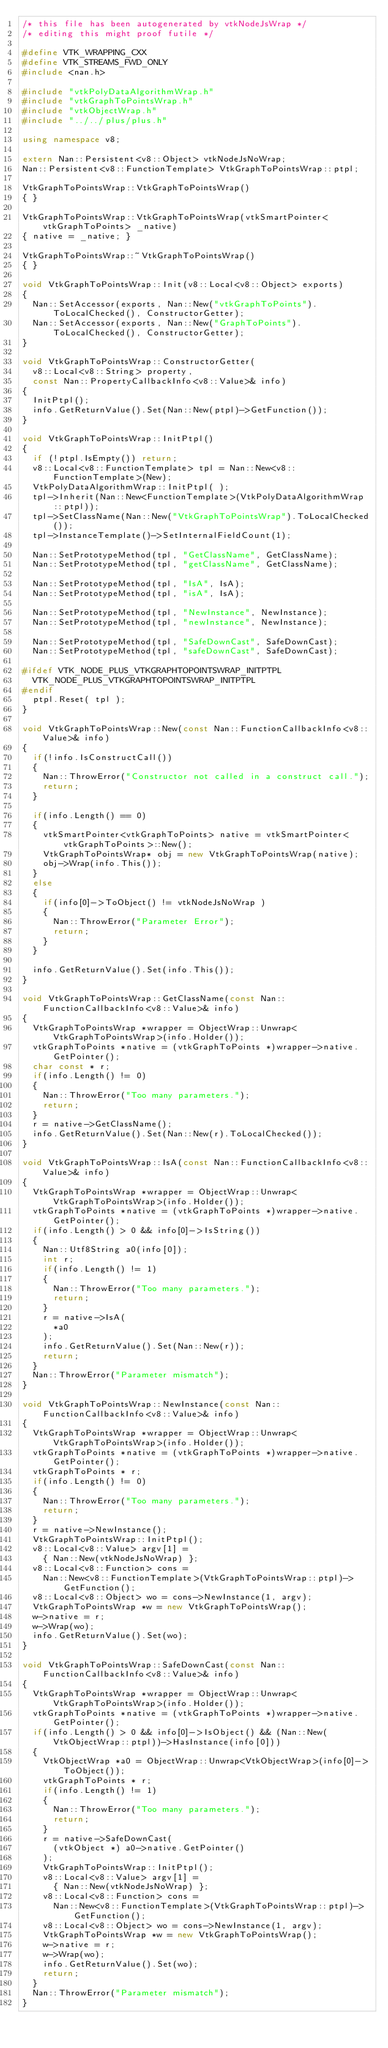Convert code to text. <code><loc_0><loc_0><loc_500><loc_500><_C++_>/* this file has been autogenerated by vtkNodeJsWrap */
/* editing this might proof futile */

#define VTK_WRAPPING_CXX
#define VTK_STREAMS_FWD_ONLY
#include <nan.h>

#include "vtkPolyDataAlgorithmWrap.h"
#include "vtkGraphToPointsWrap.h"
#include "vtkObjectWrap.h"
#include "../../plus/plus.h"

using namespace v8;

extern Nan::Persistent<v8::Object> vtkNodeJsNoWrap;
Nan::Persistent<v8::FunctionTemplate> VtkGraphToPointsWrap::ptpl;

VtkGraphToPointsWrap::VtkGraphToPointsWrap()
{ }

VtkGraphToPointsWrap::VtkGraphToPointsWrap(vtkSmartPointer<vtkGraphToPoints> _native)
{ native = _native; }

VtkGraphToPointsWrap::~VtkGraphToPointsWrap()
{ }

void VtkGraphToPointsWrap::Init(v8::Local<v8::Object> exports)
{
	Nan::SetAccessor(exports, Nan::New("vtkGraphToPoints").ToLocalChecked(), ConstructorGetter);
	Nan::SetAccessor(exports, Nan::New("GraphToPoints").ToLocalChecked(), ConstructorGetter);
}

void VtkGraphToPointsWrap::ConstructorGetter(
	v8::Local<v8::String> property,
	const Nan::PropertyCallbackInfo<v8::Value>& info)
{
	InitPtpl();
	info.GetReturnValue().Set(Nan::New(ptpl)->GetFunction());
}

void VtkGraphToPointsWrap::InitPtpl()
{
	if (!ptpl.IsEmpty()) return;
	v8::Local<v8::FunctionTemplate> tpl = Nan::New<v8::FunctionTemplate>(New);
	VtkPolyDataAlgorithmWrap::InitPtpl( );
	tpl->Inherit(Nan::New<FunctionTemplate>(VtkPolyDataAlgorithmWrap::ptpl));
	tpl->SetClassName(Nan::New("VtkGraphToPointsWrap").ToLocalChecked());
	tpl->InstanceTemplate()->SetInternalFieldCount(1);

	Nan::SetPrototypeMethod(tpl, "GetClassName", GetClassName);
	Nan::SetPrototypeMethod(tpl, "getClassName", GetClassName);

	Nan::SetPrototypeMethod(tpl, "IsA", IsA);
	Nan::SetPrototypeMethod(tpl, "isA", IsA);

	Nan::SetPrototypeMethod(tpl, "NewInstance", NewInstance);
	Nan::SetPrototypeMethod(tpl, "newInstance", NewInstance);

	Nan::SetPrototypeMethod(tpl, "SafeDownCast", SafeDownCast);
	Nan::SetPrototypeMethod(tpl, "safeDownCast", SafeDownCast);

#ifdef VTK_NODE_PLUS_VTKGRAPHTOPOINTSWRAP_INITPTPL
	VTK_NODE_PLUS_VTKGRAPHTOPOINTSWRAP_INITPTPL
#endif
	ptpl.Reset( tpl );
}

void VtkGraphToPointsWrap::New(const Nan::FunctionCallbackInfo<v8::Value>& info)
{
	if(!info.IsConstructCall())
	{
		Nan::ThrowError("Constructor not called in a construct call.");
		return;
	}

	if(info.Length() == 0)
	{
		vtkSmartPointer<vtkGraphToPoints> native = vtkSmartPointer<vtkGraphToPoints>::New();
		VtkGraphToPointsWrap* obj = new VtkGraphToPointsWrap(native);
		obj->Wrap(info.This());
	}
	else
	{
		if(info[0]->ToObject() != vtkNodeJsNoWrap )
		{
			Nan::ThrowError("Parameter Error");
			return;
		}
	}

	info.GetReturnValue().Set(info.This());
}

void VtkGraphToPointsWrap::GetClassName(const Nan::FunctionCallbackInfo<v8::Value>& info)
{
	VtkGraphToPointsWrap *wrapper = ObjectWrap::Unwrap<VtkGraphToPointsWrap>(info.Holder());
	vtkGraphToPoints *native = (vtkGraphToPoints *)wrapper->native.GetPointer();
	char const * r;
	if(info.Length() != 0)
	{
		Nan::ThrowError("Too many parameters.");
		return;
	}
	r = native->GetClassName();
	info.GetReturnValue().Set(Nan::New(r).ToLocalChecked());
}

void VtkGraphToPointsWrap::IsA(const Nan::FunctionCallbackInfo<v8::Value>& info)
{
	VtkGraphToPointsWrap *wrapper = ObjectWrap::Unwrap<VtkGraphToPointsWrap>(info.Holder());
	vtkGraphToPoints *native = (vtkGraphToPoints *)wrapper->native.GetPointer();
	if(info.Length() > 0 && info[0]->IsString())
	{
		Nan::Utf8String a0(info[0]);
		int r;
		if(info.Length() != 1)
		{
			Nan::ThrowError("Too many parameters.");
			return;
		}
		r = native->IsA(
			*a0
		);
		info.GetReturnValue().Set(Nan::New(r));
		return;
	}
	Nan::ThrowError("Parameter mismatch");
}

void VtkGraphToPointsWrap::NewInstance(const Nan::FunctionCallbackInfo<v8::Value>& info)
{
	VtkGraphToPointsWrap *wrapper = ObjectWrap::Unwrap<VtkGraphToPointsWrap>(info.Holder());
	vtkGraphToPoints *native = (vtkGraphToPoints *)wrapper->native.GetPointer();
	vtkGraphToPoints * r;
	if(info.Length() != 0)
	{
		Nan::ThrowError("Too many parameters.");
		return;
	}
	r = native->NewInstance();
	VtkGraphToPointsWrap::InitPtpl();
	v8::Local<v8::Value> argv[1] =
		{ Nan::New(vtkNodeJsNoWrap) };
	v8::Local<v8::Function> cons =
		Nan::New<v8::FunctionTemplate>(VtkGraphToPointsWrap::ptpl)->GetFunction();
	v8::Local<v8::Object> wo = cons->NewInstance(1, argv);
	VtkGraphToPointsWrap *w = new VtkGraphToPointsWrap();
	w->native = r;
	w->Wrap(wo);
	info.GetReturnValue().Set(wo);
}

void VtkGraphToPointsWrap::SafeDownCast(const Nan::FunctionCallbackInfo<v8::Value>& info)
{
	VtkGraphToPointsWrap *wrapper = ObjectWrap::Unwrap<VtkGraphToPointsWrap>(info.Holder());
	vtkGraphToPoints *native = (vtkGraphToPoints *)wrapper->native.GetPointer();
	if(info.Length() > 0 && info[0]->IsObject() && (Nan::New(VtkObjectWrap::ptpl))->HasInstance(info[0]))
	{
		VtkObjectWrap *a0 = ObjectWrap::Unwrap<VtkObjectWrap>(info[0]->ToObject());
		vtkGraphToPoints * r;
		if(info.Length() != 1)
		{
			Nan::ThrowError("Too many parameters.");
			return;
		}
		r = native->SafeDownCast(
			(vtkObject *) a0->native.GetPointer()
		);
		VtkGraphToPointsWrap::InitPtpl();
		v8::Local<v8::Value> argv[1] =
			{ Nan::New(vtkNodeJsNoWrap) };
		v8::Local<v8::Function> cons =
			Nan::New<v8::FunctionTemplate>(VtkGraphToPointsWrap::ptpl)->GetFunction();
		v8::Local<v8::Object> wo = cons->NewInstance(1, argv);
		VtkGraphToPointsWrap *w = new VtkGraphToPointsWrap();
		w->native = r;
		w->Wrap(wo);
		info.GetReturnValue().Set(wo);
		return;
	}
	Nan::ThrowError("Parameter mismatch");
}

</code> 